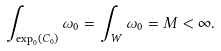<formula> <loc_0><loc_0><loc_500><loc_500>\int _ { \exp _ { 0 } ( C _ { 0 } ) } \omega _ { 0 } = \int _ { W } \omega _ { 0 } = M < \infty .</formula> 